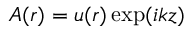<formula> <loc_0><loc_0><loc_500><loc_500>A ( r ) = u ( r ) \exp ( i k z )</formula> 